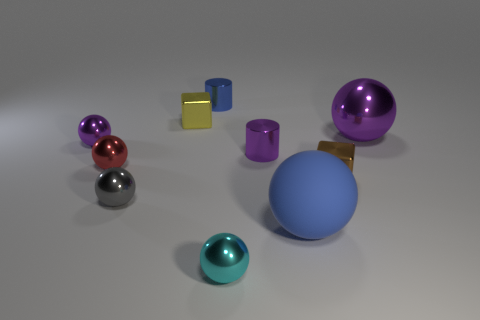Subtract 2 balls. How many balls are left? 4 Subtract all gray spheres. How many spheres are left? 5 Subtract all gray metal balls. How many balls are left? 5 Subtract all red balls. Subtract all purple blocks. How many balls are left? 5 Subtract all cylinders. How many objects are left? 8 Add 6 blue matte objects. How many blue matte objects exist? 7 Subtract 0 blue blocks. How many objects are left? 10 Subtract all gray spheres. Subtract all tiny blue cylinders. How many objects are left? 8 Add 3 blue cylinders. How many blue cylinders are left? 4 